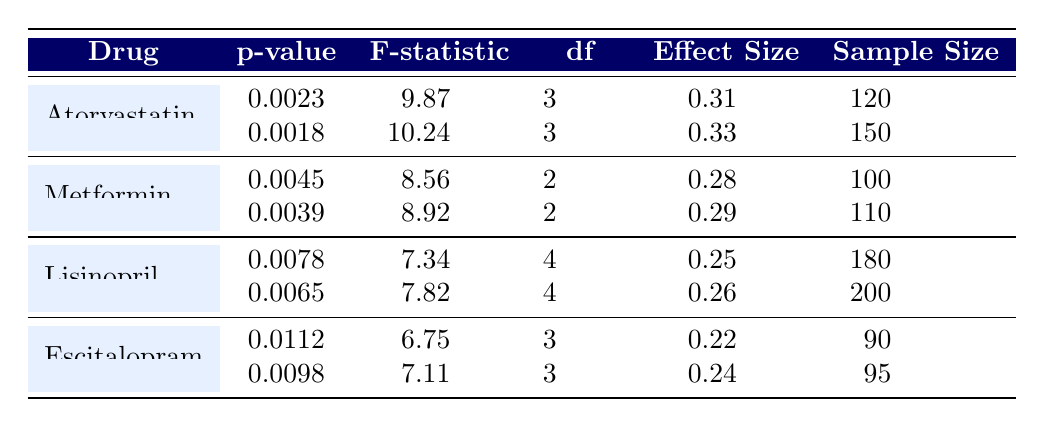What is the p-value for the second trial of Atorvastatin? Referring to the table, the second trial of Atorvastatin has a listed p-value of 0.0018.
Answer: 0.0018 What is the effect size for Metformin in its first trial? The table indicates that the effect size for Metformin in its first trial is 0.28.
Answer: 0.28 Is the F-statistic for Escitalopram higher in the second trial than in the first trial? Comparing the F-statistic values from the table, the first trial of Escitalopram has an F-statistic of 6.75, while the second trial has a value of 7.11; hence, the statement is true.
Answer: Yes What is the average sample size across all trials of Lisinopril? The sample sizes for Lisinopril trials are 180 and 200. To find the average sample size, we sum the values (180 + 200 = 380) and divide by the number of trials (2), resulting in an average of 190.
Answer: 190 Which drug has the lowest p-value across all trials? By examining the p-values from the table, Atorvastatin has the lowest p-values of 0.0023 and 0.0018 compared to other drugs. The final verdict is based on the lowest value of 0.0018 from trial two of Atorvastatin.
Answer: Atorvastatin What is the difference in effect size between the first and second trials of Lisinopril? The effect sizes for the first and second trials of Lisinopril are 0.25 and 0.26 respectively. The difference is calculated by subtracting the first trial effect size from the second: 0.26 - 0.25 = 0.01.
Answer: 0.01 How many trials of Metformin have a p-value less than 0.0040? From the table, the p-values for Metformin are 0.0045 and 0.0039. Only the second trial has a value that is less than 0.0040, thereby counting 1 trial.
Answer: 1 Is the effect size for Escitalopram greater than 0.25 in its trials? In the table, the effect sizes for Escitalopram in its trials are 0.22 and 0.24, both of which are less than 0.25, making the statement false.
Answer: No 